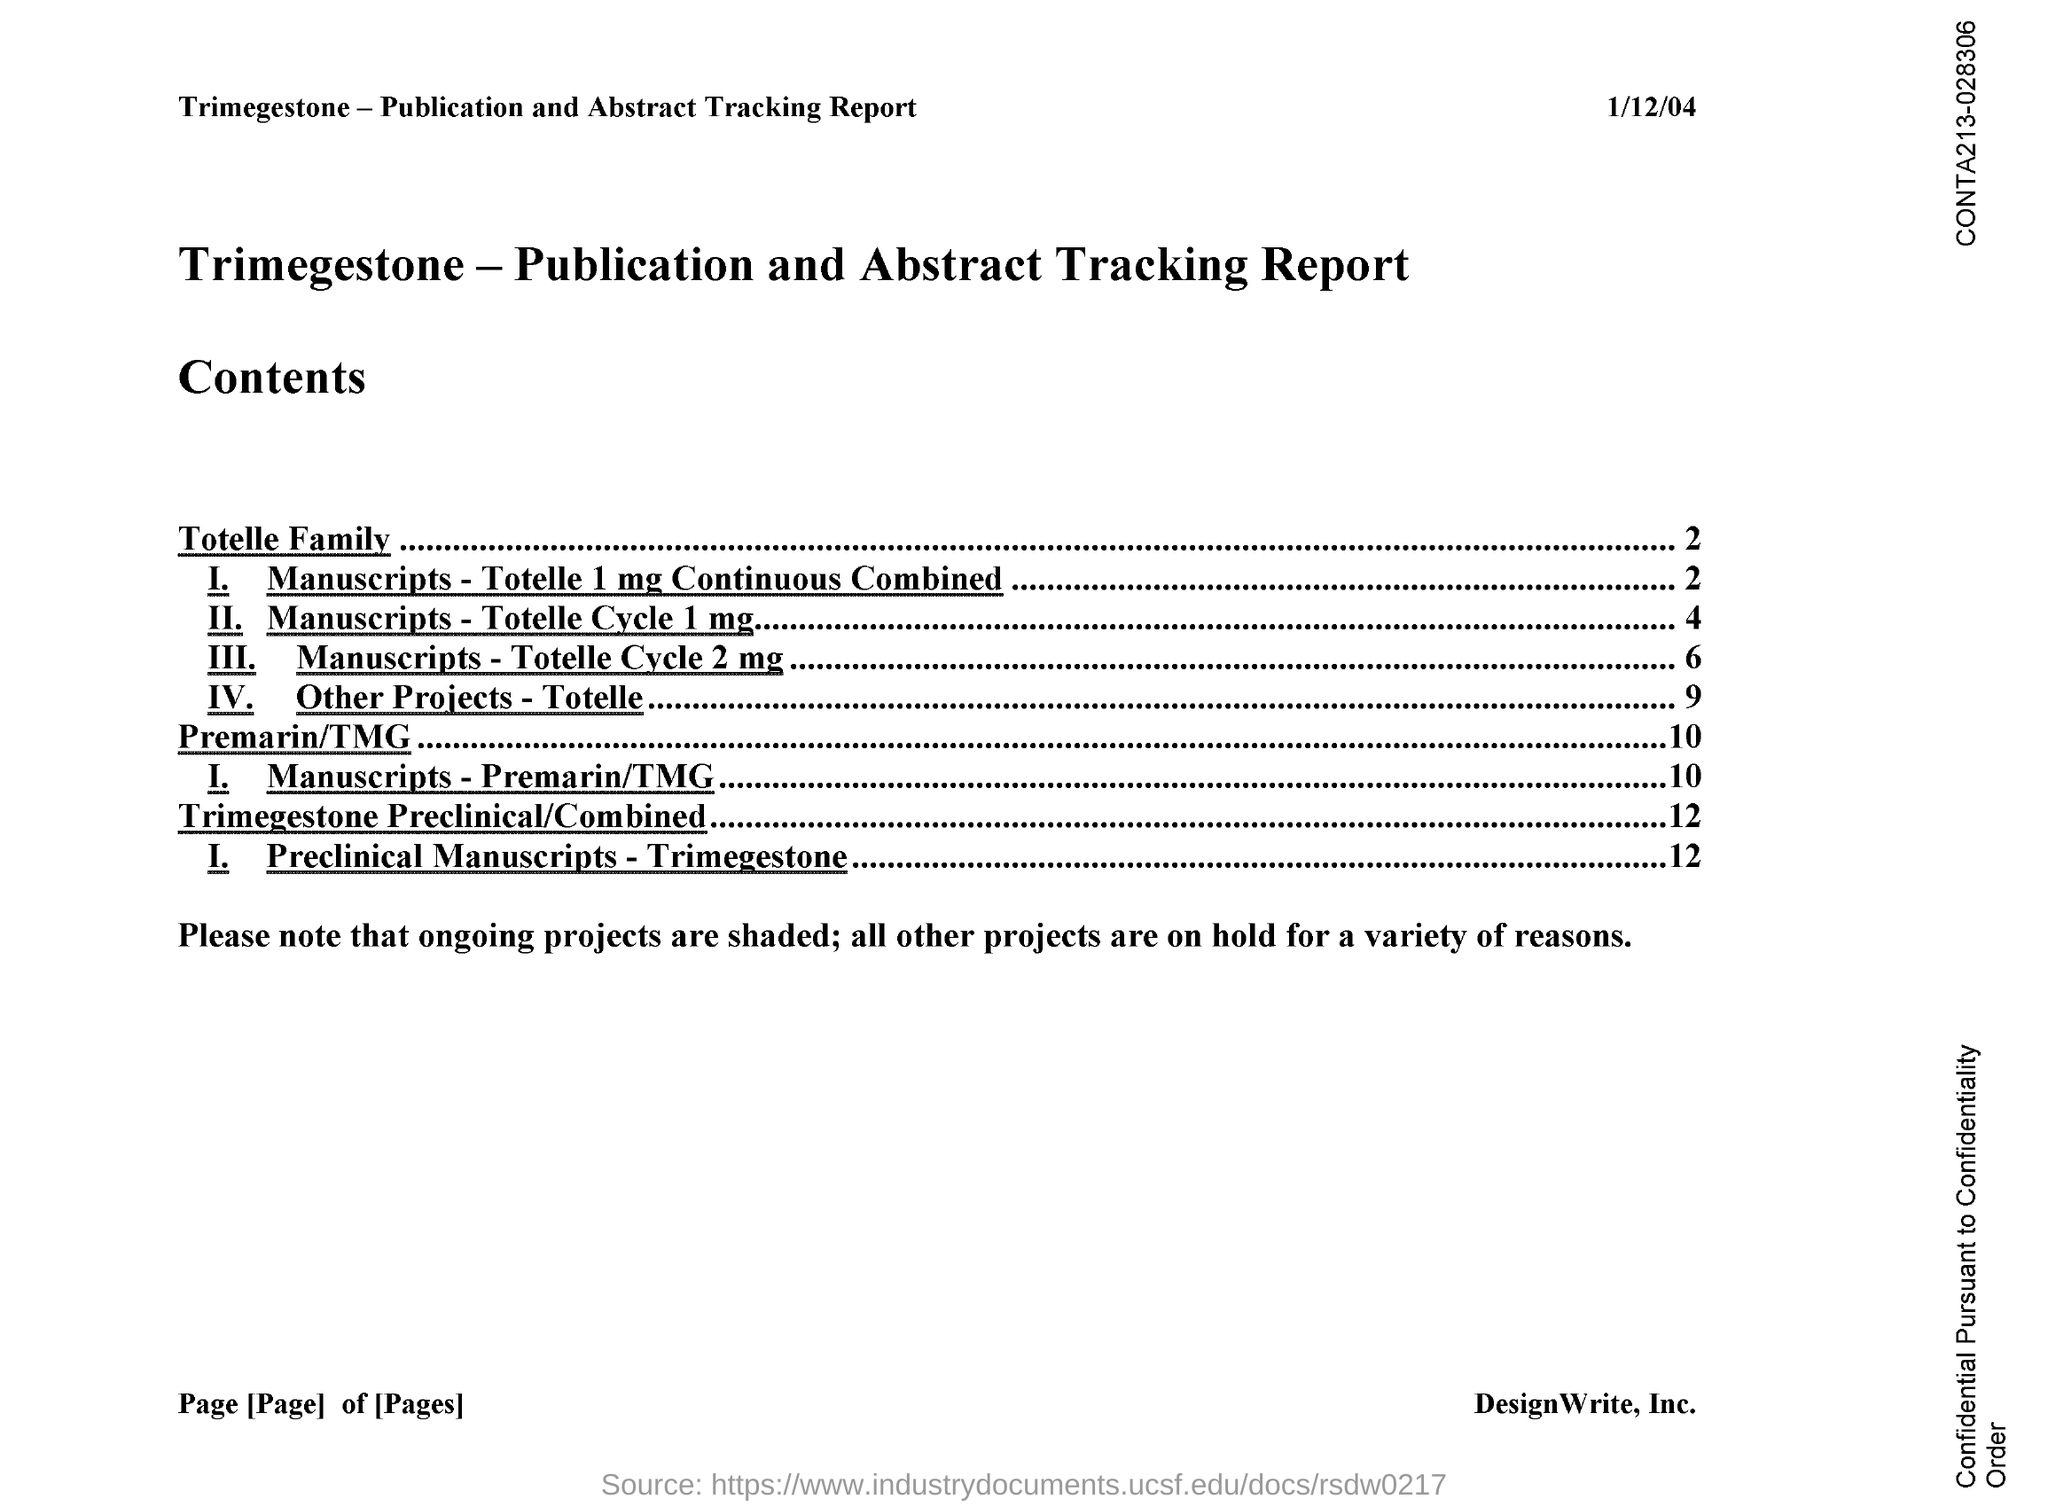What is the date on the document?
Your response must be concise. 1/12/04. All the projects are on hold for what?
Give a very brief answer. A variety of reasons. 